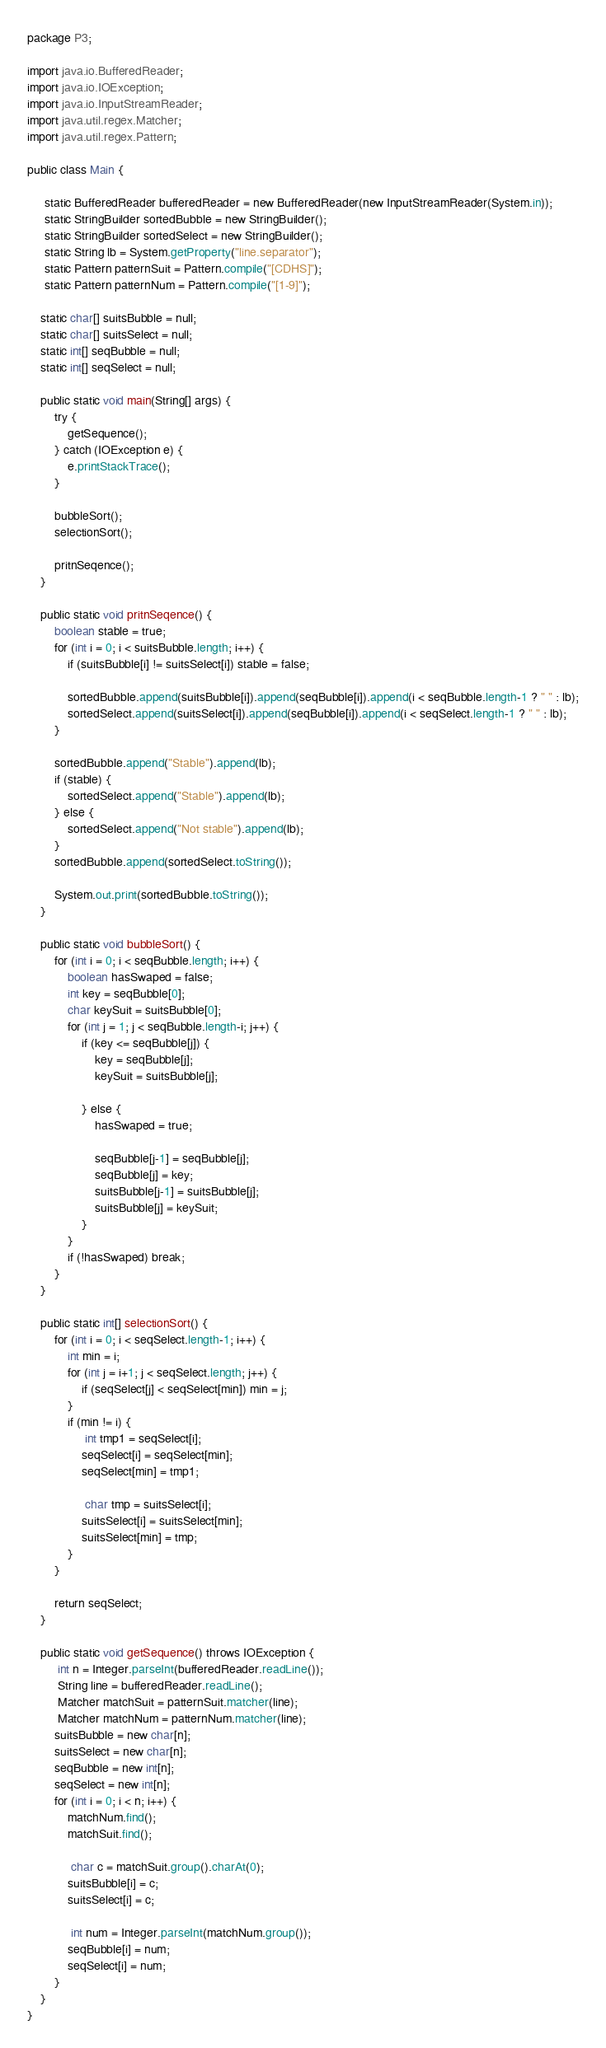<code> <loc_0><loc_0><loc_500><loc_500><_Java_>package P3;

import java.io.BufferedReader;
import java.io.IOException;
import java.io.InputStreamReader;
import java.util.regex.Matcher;
import java.util.regex.Pattern;
 
public class Main {
     
     static BufferedReader bufferedReader = new BufferedReader(new InputStreamReader(System.in));
     static StringBuilder sortedBubble = new StringBuilder();
     static StringBuilder sortedSelect = new StringBuilder();
     static String lb = System.getProperty("line.separator");
     static Pattern patternSuit = Pattern.compile("[CDHS]");
     static Pattern patternNum = Pattern.compile("[1-9]");
     
    static char[] suitsBubble = null;
    static char[] suitsSelect = null;
    static int[] seqBubble = null;
    static int[] seqSelect = null;
     
    public static void main(String[] args) {
        try {
            getSequence();
        } catch (IOException e) {
            e.printStackTrace();
        }
         
        bubbleSort();
        selectionSort();
         
        pritnSeqence();
    }
     
    public static void pritnSeqence() {
        boolean stable = true;
        for (int i = 0; i < suitsBubble.length; i++) {
            if (suitsBubble[i] != suitsSelect[i]) stable = false;
             
            sortedBubble.append(suitsBubble[i]).append(seqBubble[i]).append(i < seqBubble.length-1 ? " " : lb);
            sortedSelect.append(suitsSelect[i]).append(seqBubble[i]).append(i < seqSelect.length-1 ? " " : lb);
        }
         
        sortedBubble.append("Stable").append(lb);
        if (stable) {
            sortedSelect.append("Stable").append(lb);
        } else {
            sortedSelect.append("Not stable").append(lb);
        }
        sortedBubble.append(sortedSelect.toString());
         
        System.out.print(sortedBubble.toString());
    }
     
    public static void bubbleSort() {
        for (int i = 0; i < seqBubble.length; i++) {
            boolean hasSwaped = false;
            int key = seqBubble[0];
            char keySuit = suitsBubble[0];
            for (int j = 1; j < seqBubble.length-i; j++) {
                if (key <= seqBubble[j]) {
                    key = seqBubble[j];
                    keySuit = suitsBubble[j];
                     
                } else {
                    hasSwaped = true;
                     
                    seqBubble[j-1] = seqBubble[j];
                    seqBubble[j] = key;
                    suitsBubble[j-1] = suitsBubble[j];
                    suitsBubble[j] = keySuit;
                }
            }
            if (!hasSwaped) break;
        }
    }
     
    public static int[] selectionSort() {
        for (int i = 0; i < seqSelect.length-1; i++) {
            int min = i;
            for (int j = i+1; j < seqSelect.length; j++) {
                if (seqSelect[j] < seqSelect[min]) min = j;
            }
            if (min != i) {
                 int tmp1 = seqSelect[i];
                seqSelect[i] = seqSelect[min];
                seqSelect[min] = tmp1;
                 
                 char tmp = suitsSelect[i];
                suitsSelect[i] = suitsSelect[min];
                suitsSelect[min] = tmp;
            }
        }
 
        return seqSelect;
    }
     
    public static void getSequence() throws IOException {
         int n = Integer.parseInt(bufferedReader.readLine());
         String line = bufferedReader.readLine();
         Matcher matchSuit = patternSuit.matcher(line);
         Matcher matchNum = patternNum.matcher(line);
        suitsBubble = new char[n];
        suitsSelect = new char[n];
        seqBubble = new int[n];
        seqSelect = new int[n];
        for (int i = 0; i < n; i++) {
            matchNum.find();
            matchSuit.find();
             
             char c = matchSuit.group().charAt(0);
            suitsBubble[i] = c;
            suitsSelect[i] = c;
             
             int num = Integer.parseInt(matchNum.group());
            seqBubble[i] = num;
            seqSelect[i] = num;
        }
    }
}</code> 